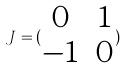Convert formula to latex. <formula><loc_0><loc_0><loc_500><loc_500>J = ( \begin{matrix} 0 & 1 \\ - 1 & 0 \end{matrix} )</formula> 